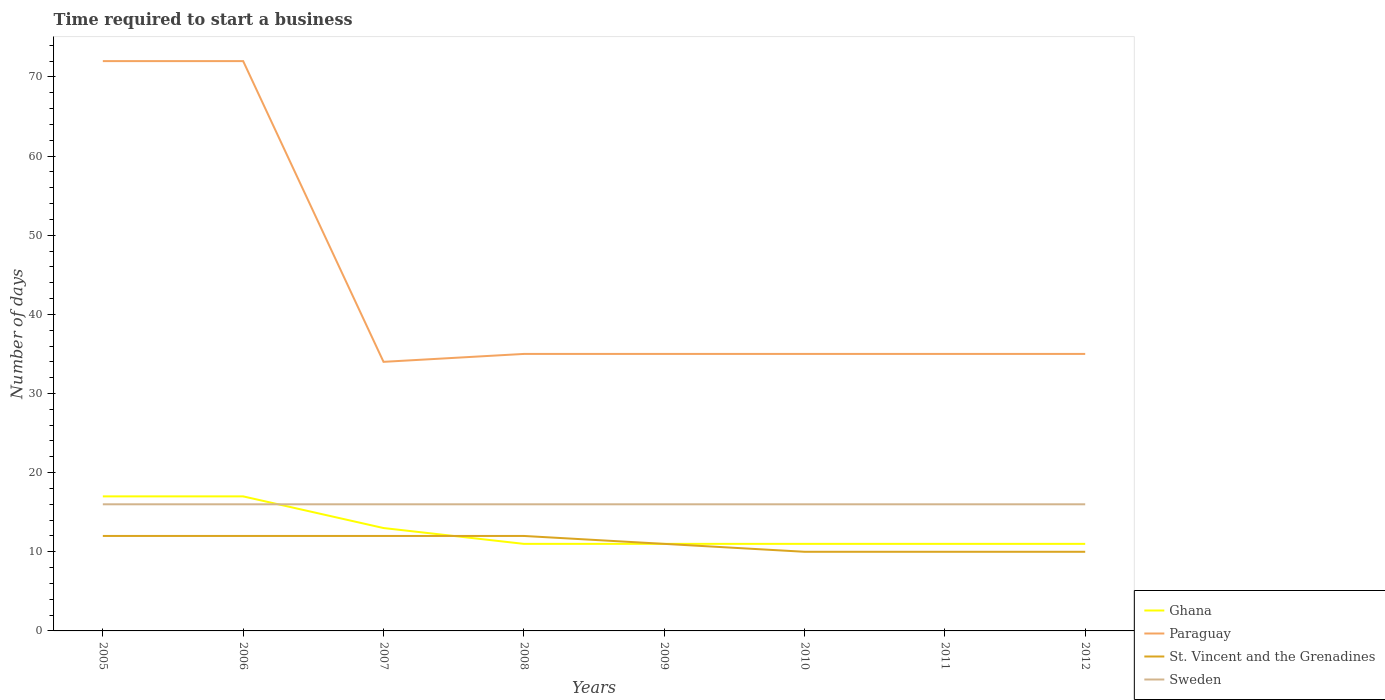How many different coloured lines are there?
Provide a short and direct response. 4. Across all years, what is the maximum number of days required to start a business in Paraguay?
Make the answer very short. 34. In which year was the number of days required to start a business in Sweden maximum?
Ensure brevity in your answer.  2005. What is the difference between the highest and the second highest number of days required to start a business in Sweden?
Your response must be concise. 0. What is the difference between the highest and the lowest number of days required to start a business in Sweden?
Your answer should be compact. 0. How many lines are there?
Provide a succinct answer. 4. Does the graph contain any zero values?
Offer a terse response. No. Does the graph contain grids?
Offer a very short reply. No. Where does the legend appear in the graph?
Offer a terse response. Bottom right. What is the title of the graph?
Give a very brief answer. Time required to start a business. Does "France" appear as one of the legend labels in the graph?
Provide a succinct answer. No. What is the label or title of the Y-axis?
Your answer should be very brief. Number of days. What is the Number of days of St. Vincent and the Grenadines in 2005?
Your answer should be compact. 12. What is the Number of days of Sweden in 2005?
Give a very brief answer. 16. What is the Number of days of Ghana in 2008?
Keep it short and to the point. 11. What is the Number of days in Sweden in 2008?
Give a very brief answer. 16. What is the Number of days of Ghana in 2009?
Offer a terse response. 11. What is the Number of days of St. Vincent and the Grenadines in 2009?
Your answer should be very brief. 11. What is the Number of days in Sweden in 2009?
Keep it short and to the point. 16. What is the Number of days in Paraguay in 2010?
Your answer should be compact. 35. What is the Number of days of Sweden in 2010?
Offer a terse response. 16. What is the Number of days of Ghana in 2011?
Provide a short and direct response. 11. What is the Number of days in St. Vincent and the Grenadines in 2011?
Offer a terse response. 10. What is the Number of days in Sweden in 2011?
Offer a very short reply. 16. What is the Number of days of Ghana in 2012?
Offer a very short reply. 11. Across all years, what is the maximum Number of days of Ghana?
Keep it short and to the point. 17. Across all years, what is the maximum Number of days of St. Vincent and the Grenadines?
Give a very brief answer. 12. Across all years, what is the minimum Number of days of Ghana?
Your answer should be compact. 11. What is the total Number of days of Ghana in the graph?
Your response must be concise. 102. What is the total Number of days of Paraguay in the graph?
Your response must be concise. 353. What is the total Number of days of St. Vincent and the Grenadines in the graph?
Ensure brevity in your answer.  89. What is the total Number of days in Sweden in the graph?
Offer a terse response. 128. What is the difference between the Number of days of Paraguay in 2005 and that in 2006?
Offer a very short reply. 0. What is the difference between the Number of days of St. Vincent and the Grenadines in 2005 and that in 2006?
Provide a succinct answer. 0. What is the difference between the Number of days of Sweden in 2005 and that in 2006?
Provide a succinct answer. 0. What is the difference between the Number of days in St. Vincent and the Grenadines in 2005 and that in 2007?
Provide a succinct answer. 0. What is the difference between the Number of days of Sweden in 2005 and that in 2007?
Provide a short and direct response. 0. What is the difference between the Number of days of St. Vincent and the Grenadines in 2005 and that in 2008?
Your answer should be very brief. 0. What is the difference between the Number of days in Ghana in 2005 and that in 2009?
Your answer should be compact. 6. What is the difference between the Number of days of St. Vincent and the Grenadines in 2005 and that in 2009?
Your answer should be compact. 1. What is the difference between the Number of days in Ghana in 2005 and that in 2011?
Provide a succinct answer. 6. What is the difference between the Number of days in Paraguay in 2005 and that in 2011?
Offer a very short reply. 37. What is the difference between the Number of days of Sweden in 2005 and that in 2011?
Offer a terse response. 0. What is the difference between the Number of days of Ghana in 2005 and that in 2012?
Make the answer very short. 6. What is the difference between the Number of days in Paraguay in 2005 and that in 2012?
Offer a very short reply. 37. What is the difference between the Number of days of St. Vincent and the Grenadines in 2005 and that in 2012?
Your answer should be very brief. 2. What is the difference between the Number of days in St. Vincent and the Grenadines in 2006 and that in 2007?
Make the answer very short. 0. What is the difference between the Number of days in Sweden in 2006 and that in 2007?
Ensure brevity in your answer.  0. What is the difference between the Number of days of Paraguay in 2006 and that in 2008?
Make the answer very short. 37. What is the difference between the Number of days of Sweden in 2006 and that in 2008?
Offer a terse response. 0. What is the difference between the Number of days in St. Vincent and the Grenadines in 2006 and that in 2009?
Make the answer very short. 1. What is the difference between the Number of days in Sweden in 2006 and that in 2009?
Provide a succinct answer. 0. What is the difference between the Number of days of Paraguay in 2006 and that in 2010?
Offer a very short reply. 37. What is the difference between the Number of days in Ghana in 2006 and that in 2011?
Make the answer very short. 6. What is the difference between the Number of days of Paraguay in 2006 and that in 2011?
Keep it short and to the point. 37. What is the difference between the Number of days in St. Vincent and the Grenadines in 2006 and that in 2011?
Your answer should be compact. 2. What is the difference between the Number of days of Ghana in 2006 and that in 2012?
Keep it short and to the point. 6. What is the difference between the Number of days of Sweden in 2006 and that in 2012?
Provide a short and direct response. 0. What is the difference between the Number of days in Ghana in 2007 and that in 2008?
Make the answer very short. 2. What is the difference between the Number of days in Paraguay in 2007 and that in 2008?
Provide a short and direct response. -1. What is the difference between the Number of days in St. Vincent and the Grenadines in 2007 and that in 2008?
Provide a succinct answer. 0. What is the difference between the Number of days in Paraguay in 2007 and that in 2009?
Offer a very short reply. -1. What is the difference between the Number of days of St. Vincent and the Grenadines in 2007 and that in 2009?
Your answer should be compact. 1. What is the difference between the Number of days in St. Vincent and the Grenadines in 2007 and that in 2010?
Provide a succinct answer. 2. What is the difference between the Number of days of Ghana in 2007 and that in 2011?
Your answer should be compact. 2. What is the difference between the Number of days of Ghana in 2007 and that in 2012?
Your answer should be compact. 2. What is the difference between the Number of days of Paraguay in 2007 and that in 2012?
Make the answer very short. -1. What is the difference between the Number of days in St. Vincent and the Grenadines in 2007 and that in 2012?
Your answer should be very brief. 2. What is the difference between the Number of days in Ghana in 2008 and that in 2009?
Ensure brevity in your answer.  0. What is the difference between the Number of days of Paraguay in 2008 and that in 2009?
Your answer should be very brief. 0. What is the difference between the Number of days in Ghana in 2008 and that in 2010?
Offer a terse response. 0. What is the difference between the Number of days of St. Vincent and the Grenadines in 2008 and that in 2010?
Offer a terse response. 2. What is the difference between the Number of days of St. Vincent and the Grenadines in 2008 and that in 2011?
Ensure brevity in your answer.  2. What is the difference between the Number of days of Ghana in 2008 and that in 2012?
Your answer should be very brief. 0. What is the difference between the Number of days of Paraguay in 2008 and that in 2012?
Your response must be concise. 0. What is the difference between the Number of days in St. Vincent and the Grenadines in 2008 and that in 2012?
Make the answer very short. 2. What is the difference between the Number of days in Sweden in 2008 and that in 2012?
Offer a terse response. 0. What is the difference between the Number of days in Paraguay in 2009 and that in 2010?
Provide a succinct answer. 0. What is the difference between the Number of days of St. Vincent and the Grenadines in 2009 and that in 2010?
Offer a terse response. 1. What is the difference between the Number of days in Sweden in 2009 and that in 2010?
Your response must be concise. 0. What is the difference between the Number of days of Paraguay in 2009 and that in 2011?
Offer a terse response. 0. What is the difference between the Number of days in St. Vincent and the Grenadines in 2009 and that in 2011?
Provide a succinct answer. 1. What is the difference between the Number of days of Paraguay in 2009 and that in 2012?
Keep it short and to the point. 0. What is the difference between the Number of days of Sweden in 2010 and that in 2012?
Offer a very short reply. 0. What is the difference between the Number of days of Ghana in 2011 and that in 2012?
Provide a short and direct response. 0. What is the difference between the Number of days in Paraguay in 2011 and that in 2012?
Keep it short and to the point. 0. What is the difference between the Number of days of Sweden in 2011 and that in 2012?
Give a very brief answer. 0. What is the difference between the Number of days in Ghana in 2005 and the Number of days in Paraguay in 2006?
Give a very brief answer. -55. What is the difference between the Number of days of Paraguay in 2005 and the Number of days of St. Vincent and the Grenadines in 2006?
Make the answer very short. 60. What is the difference between the Number of days in Paraguay in 2005 and the Number of days in Sweden in 2006?
Offer a very short reply. 56. What is the difference between the Number of days of St. Vincent and the Grenadines in 2005 and the Number of days of Sweden in 2006?
Give a very brief answer. -4. What is the difference between the Number of days of Ghana in 2005 and the Number of days of Paraguay in 2007?
Provide a succinct answer. -17. What is the difference between the Number of days in Ghana in 2005 and the Number of days in Sweden in 2007?
Ensure brevity in your answer.  1. What is the difference between the Number of days in St. Vincent and the Grenadines in 2005 and the Number of days in Sweden in 2007?
Give a very brief answer. -4. What is the difference between the Number of days in Ghana in 2005 and the Number of days in St. Vincent and the Grenadines in 2008?
Give a very brief answer. 5. What is the difference between the Number of days in Ghana in 2005 and the Number of days in Sweden in 2008?
Ensure brevity in your answer.  1. What is the difference between the Number of days in Paraguay in 2005 and the Number of days in St. Vincent and the Grenadines in 2008?
Your answer should be very brief. 60. What is the difference between the Number of days in Paraguay in 2005 and the Number of days in Sweden in 2008?
Give a very brief answer. 56. What is the difference between the Number of days in St. Vincent and the Grenadines in 2005 and the Number of days in Sweden in 2009?
Keep it short and to the point. -4. What is the difference between the Number of days in Ghana in 2005 and the Number of days in St. Vincent and the Grenadines in 2010?
Make the answer very short. 7. What is the difference between the Number of days in Ghana in 2005 and the Number of days in Sweden in 2010?
Provide a short and direct response. 1. What is the difference between the Number of days in St. Vincent and the Grenadines in 2005 and the Number of days in Sweden in 2010?
Make the answer very short. -4. What is the difference between the Number of days in Ghana in 2005 and the Number of days in St. Vincent and the Grenadines in 2011?
Your answer should be compact. 7. What is the difference between the Number of days in Paraguay in 2005 and the Number of days in Sweden in 2011?
Provide a succinct answer. 56. What is the difference between the Number of days of St. Vincent and the Grenadines in 2005 and the Number of days of Sweden in 2011?
Provide a short and direct response. -4. What is the difference between the Number of days in Paraguay in 2005 and the Number of days in Sweden in 2012?
Ensure brevity in your answer.  56. What is the difference between the Number of days of St. Vincent and the Grenadines in 2005 and the Number of days of Sweden in 2012?
Your answer should be very brief. -4. What is the difference between the Number of days of Ghana in 2006 and the Number of days of Sweden in 2007?
Offer a terse response. 1. What is the difference between the Number of days of Paraguay in 2006 and the Number of days of St. Vincent and the Grenadines in 2007?
Keep it short and to the point. 60. What is the difference between the Number of days of Paraguay in 2006 and the Number of days of Sweden in 2007?
Your answer should be compact. 56. What is the difference between the Number of days of Ghana in 2006 and the Number of days of Paraguay in 2008?
Give a very brief answer. -18. What is the difference between the Number of days of Ghana in 2006 and the Number of days of St. Vincent and the Grenadines in 2008?
Make the answer very short. 5. What is the difference between the Number of days in Ghana in 2006 and the Number of days in Sweden in 2008?
Make the answer very short. 1. What is the difference between the Number of days in Paraguay in 2006 and the Number of days in Sweden in 2008?
Make the answer very short. 56. What is the difference between the Number of days in St. Vincent and the Grenadines in 2006 and the Number of days in Sweden in 2008?
Your answer should be very brief. -4. What is the difference between the Number of days in Ghana in 2006 and the Number of days in Paraguay in 2009?
Keep it short and to the point. -18. What is the difference between the Number of days of Paraguay in 2006 and the Number of days of St. Vincent and the Grenadines in 2009?
Provide a short and direct response. 61. What is the difference between the Number of days of Paraguay in 2006 and the Number of days of Sweden in 2009?
Ensure brevity in your answer.  56. What is the difference between the Number of days in Ghana in 2006 and the Number of days in Paraguay in 2010?
Provide a short and direct response. -18. What is the difference between the Number of days in Ghana in 2006 and the Number of days in St. Vincent and the Grenadines in 2010?
Give a very brief answer. 7. What is the difference between the Number of days in Ghana in 2006 and the Number of days in Sweden in 2010?
Your answer should be compact. 1. What is the difference between the Number of days in Paraguay in 2006 and the Number of days in St. Vincent and the Grenadines in 2010?
Provide a short and direct response. 62. What is the difference between the Number of days of Paraguay in 2006 and the Number of days of Sweden in 2010?
Provide a succinct answer. 56. What is the difference between the Number of days in Paraguay in 2006 and the Number of days in Sweden in 2011?
Offer a terse response. 56. What is the difference between the Number of days of St. Vincent and the Grenadines in 2006 and the Number of days of Sweden in 2011?
Provide a succinct answer. -4. What is the difference between the Number of days in Ghana in 2006 and the Number of days in St. Vincent and the Grenadines in 2012?
Your response must be concise. 7. What is the difference between the Number of days of Ghana in 2006 and the Number of days of Sweden in 2012?
Ensure brevity in your answer.  1. What is the difference between the Number of days in St. Vincent and the Grenadines in 2006 and the Number of days in Sweden in 2012?
Offer a terse response. -4. What is the difference between the Number of days of Ghana in 2007 and the Number of days of Paraguay in 2008?
Offer a very short reply. -22. What is the difference between the Number of days of Paraguay in 2007 and the Number of days of Sweden in 2008?
Your answer should be very brief. 18. What is the difference between the Number of days of St. Vincent and the Grenadines in 2007 and the Number of days of Sweden in 2008?
Your answer should be very brief. -4. What is the difference between the Number of days of Ghana in 2007 and the Number of days of Paraguay in 2009?
Make the answer very short. -22. What is the difference between the Number of days of Ghana in 2007 and the Number of days of St. Vincent and the Grenadines in 2009?
Your answer should be very brief. 2. What is the difference between the Number of days of Paraguay in 2007 and the Number of days of St. Vincent and the Grenadines in 2009?
Offer a very short reply. 23. What is the difference between the Number of days of Ghana in 2007 and the Number of days of Paraguay in 2010?
Your answer should be very brief. -22. What is the difference between the Number of days in Ghana in 2007 and the Number of days in Sweden in 2010?
Your response must be concise. -3. What is the difference between the Number of days in Paraguay in 2007 and the Number of days in St. Vincent and the Grenadines in 2010?
Offer a very short reply. 24. What is the difference between the Number of days in Paraguay in 2007 and the Number of days in Sweden in 2010?
Offer a terse response. 18. What is the difference between the Number of days in Ghana in 2007 and the Number of days in Paraguay in 2011?
Offer a terse response. -22. What is the difference between the Number of days in Paraguay in 2007 and the Number of days in St. Vincent and the Grenadines in 2011?
Provide a short and direct response. 24. What is the difference between the Number of days of Ghana in 2007 and the Number of days of St. Vincent and the Grenadines in 2012?
Provide a succinct answer. 3. What is the difference between the Number of days in Ghana in 2007 and the Number of days in Sweden in 2012?
Offer a very short reply. -3. What is the difference between the Number of days in Paraguay in 2007 and the Number of days in St. Vincent and the Grenadines in 2012?
Make the answer very short. 24. What is the difference between the Number of days in St. Vincent and the Grenadines in 2007 and the Number of days in Sweden in 2012?
Offer a very short reply. -4. What is the difference between the Number of days in Ghana in 2008 and the Number of days in Paraguay in 2009?
Your answer should be very brief. -24. What is the difference between the Number of days of Ghana in 2008 and the Number of days of Sweden in 2009?
Keep it short and to the point. -5. What is the difference between the Number of days of Ghana in 2008 and the Number of days of Sweden in 2010?
Give a very brief answer. -5. What is the difference between the Number of days of Paraguay in 2008 and the Number of days of Sweden in 2010?
Make the answer very short. 19. What is the difference between the Number of days in St. Vincent and the Grenadines in 2008 and the Number of days in Sweden in 2010?
Provide a short and direct response. -4. What is the difference between the Number of days of Ghana in 2008 and the Number of days of Paraguay in 2011?
Offer a very short reply. -24. What is the difference between the Number of days of Ghana in 2008 and the Number of days of Sweden in 2011?
Your answer should be compact. -5. What is the difference between the Number of days of Paraguay in 2008 and the Number of days of Sweden in 2011?
Offer a very short reply. 19. What is the difference between the Number of days in St. Vincent and the Grenadines in 2008 and the Number of days in Sweden in 2011?
Make the answer very short. -4. What is the difference between the Number of days in Ghana in 2008 and the Number of days in Paraguay in 2012?
Your answer should be compact. -24. What is the difference between the Number of days in Ghana in 2008 and the Number of days in Sweden in 2012?
Your answer should be compact. -5. What is the difference between the Number of days of St. Vincent and the Grenadines in 2008 and the Number of days of Sweden in 2012?
Your answer should be very brief. -4. What is the difference between the Number of days in Ghana in 2009 and the Number of days in St. Vincent and the Grenadines in 2010?
Ensure brevity in your answer.  1. What is the difference between the Number of days of Paraguay in 2009 and the Number of days of St. Vincent and the Grenadines in 2010?
Offer a terse response. 25. What is the difference between the Number of days of Paraguay in 2009 and the Number of days of St. Vincent and the Grenadines in 2011?
Provide a short and direct response. 25. What is the difference between the Number of days of Ghana in 2009 and the Number of days of Paraguay in 2012?
Your answer should be very brief. -24. What is the difference between the Number of days in Ghana in 2009 and the Number of days in St. Vincent and the Grenadines in 2012?
Your answer should be very brief. 1. What is the difference between the Number of days of St. Vincent and the Grenadines in 2009 and the Number of days of Sweden in 2012?
Offer a terse response. -5. What is the difference between the Number of days in Ghana in 2010 and the Number of days in Paraguay in 2011?
Your answer should be compact. -24. What is the difference between the Number of days in Ghana in 2010 and the Number of days in St. Vincent and the Grenadines in 2011?
Keep it short and to the point. 1. What is the difference between the Number of days of Ghana in 2010 and the Number of days of Sweden in 2011?
Your response must be concise. -5. What is the difference between the Number of days of Paraguay in 2010 and the Number of days of Sweden in 2011?
Your response must be concise. 19. What is the difference between the Number of days in St. Vincent and the Grenadines in 2010 and the Number of days in Sweden in 2011?
Ensure brevity in your answer.  -6. What is the difference between the Number of days of Paraguay in 2010 and the Number of days of St. Vincent and the Grenadines in 2012?
Your answer should be compact. 25. What is the difference between the Number of days in Ghana in 2011 and the Number of days in St. Vincent and the Grenadines in 2012?
Offer a very short reply. 1. What is the difference between the Number of days of Ghana in 2011 and the Number of days of Sweden in 2012?
Your response must be concise. -5. What is the difference between the Number of days in Paraguay in 2011 and the Number of days in Sweden in 2012?
Your answer should be very brief. 19. What is the average Number of days of Ghana per year?
Give a very brief answer. 12.75. What is the average Number of days of Paraguay per year?
Ensure brevity in your answer.  44.12. What is the average Number of days in St. Vincent and the Grenadines per year?
Your answer should be compact. 11.12. What is the average Number of days in Sweden per year?
Provide a succinct answer. 16. In the year 2005, what is the difference between the Number of days of Ghana and Number of days of Paraguay?
Provide a succinct answer. -55. In the year 2005, what is the difference between the Number of days of Ghana and Number of days of Sweden?
Keep it short and to the point. 1. In the year 2006, what is the difference between the Number of days of Ghana and Number of days of Paraguay?
Provide a short and direct response. -55. In the year 2006, what is the difference between the Number of days of Paraguay and Number of days of St. Vincent and the Grenadines?
Offer a very short reply. 60. In the year 2007, what is the difference between the Number of days in Ghana and Number of days in St. Vincent and the Grenadines?
Offer a very short reply. 1. In the year 2007, what is the difference between the Number of days in Paraguay and Number of days in Sweden?
Provide a succinct answer. 18. In the year 2008, what is the difference between the Number of days in Ghana and Number of days in St. Vincent and the Grenadines?
Give a very brief answer. -1. In the year 2008, what is the difference between the Number of days of Paraguay and Number of days of St. Vincent and the Grenadines?
Provide a succinct answer. 23. In the year 2009, what is the difference between the Number of days in Ghana and Number of days in Paraguay?
Ensure brevity in your answer.  -24. In the year 2009, what is the difference between the Number of days in Ghana and Number of days in St. Vincent and the Grenadines?
Make the answer very short. 0. In the year 2009, what is the difference between the Number of days in Paraguay and Number of days in Sweden?
Give a very brief answer. 19. In the year 2010, what is the difference between the Number of days of Ghana and Number of days of Sweden?
Give a very brief answer. -5. In the year 2010, what is the difference between the Number of days in Paraguay and Number of days in Sweden?
Provide a short and direct response. 19. In the year 2010, what is the difference between the Number of days in St. Vincent and the Grenadines and Number of days in Sweden?
Offer a terse response. -6. In the year 2011, what is the difference between the Number of days in Ghana and Number of days in St. Vincent and the Grenadines?
Keep it short and to the point. 1. In the year 2011, what is the difference between the Number of days of St. Vincent and the Grenadines and Number of days of Sweden?
Provide a short and direct response. -6. In the year 2012, what is the difference between the Number of days of Ghana and Number of days of Sweden?
Give a very brief answer. -5. In the year 2012, what is the difference between the Number of days of Paraguay and Number of days of St. Vincent and the Grenadines?
Make the answer very short. 25. In the year 2012, what is the difference between the Number of days in Paraguay and Number of days in Sweden?
Offer a terse response. 19. In the year 2012, what is the difference between the Number of days in St. Vincent and the Grenadines and Number of days in Sweden?
Your response must be concise. -6. What is the ratio of the Number of days of Ghana in 2005 to that in 2006?
Give a very brief answer. 1. What is the ratio of the Number of days in Ghana in 2005 to that in 2007?
Provide a succinct answer. 1.31. What is the ratio of the Number of days of Paraguay in 2005 to that in 2007?
Your response must be concise. 2.12. What is the ratio of the Number of days in Ghana in 2005 to that in 2008?
Offer a terse response. 1.55. What is the ratio of the Number of days of Paraguay in 2005 to that in 2008?
Offer a terse response. 2.06. What is the ratio of the Number of days of St. Vincent and the Grenadines in 2005 to that in 2008?
Your answer should be compact. 1. What is the ratio of the Number of days of Sweden in 2005 to that in 2008?
Make the answer very short. 1. What is the ratio of the Number of days of Ghana in 2005 to that in 2009?
Your answer should be very brief. 1.55. What is the ratio of the Number of days of Paraguay in 2005 to that in 2009?
Ensure brevity in your answer.  2.06. What is the ratio of the Number of days of St. Vincent and the Grenadines in 2005 to that in 2009?
Provide a short and direct response. 1.09. What is the ratio of the Number of days of Ghana in 2005 to that in 2010?
Ensure brevity in your answer.  1.55. What is the ratio of the Number of days in Paraguay in 2005 to that in 2010?
Make the answer very short. 2.06. What is the ratio of the Number of days of St. Vincent and the Grenadines in 2005 to that in 2010?
Your answer should be compact. 1.2. What is the ratio of the Number of days in Ghana in 2005 to that in 2011?
Make the answer very short. 1.55. What is the ratio of the Number of days of Paraguay in 2005 to that in 2011?
Ensure brevity in your answer.  2.06. What is the ratio of the Number of days of St. Vincent and the Grenadines in 2005 to that in 2011?
Provide a short and direct response. 1.2. What is the ratio of the Number of days of Ghana in 2005 to that in 2012?
Your answer should be compact. 1.55. What is the ratio of the Number of days of Paraguay in 2005 to that in 2012?
Give a very brief answer. 2.06. What is the ratio of the Number of days of St. Vincent and the Grenadines in 2005 to that in 2012?
Your response must be concise. 1.2. What is the ratio of the Number of days of Sweden in 2005 to that in 2012?
Provide a short and direct response. 1. What is the ratio of the Number of days in Ghana in 2006 to that in 2007?
Provide a short and direct response. 1.31. What is the ratio of the Number of days of Paraguay in 2006 to that in 2007?
Ensure brevity in your answer.  2.12. What is the ratio of the Number of days of Sweden in 2006 to that in 2007?
Make the answer very short. 1. What is the ratio of the Number of days in Ghana in 2006 to that in 2008?
Your answer should be very brief. 1.55. What is the ratio of the Number of days in Paraguay in 2006 to that in 2008?
Give a very brief answer. 2.06. What is the ratio of the Number of days in St. Vincent and the Grenadines in 2006 to that in 2008?
Offer a terse response. 1. What is the ratio of the Number of days in Ghana in 2006 to that in 2009?
Make the answer very short. 1.55. What is the ratio of the Number of days of Paraguay in 2006 to that in 2009?
Provide a short and direct response. 2.06. What is the ratio of the Number of days in Sweden in 2006 to that in 2009?
Keep it short and to the point. 1. What is the ratio of the Number of days in Ghana in 2006 to that in 2010?
Make the answer very short. 1.55. What is the ratio of the Number of days of Paraguay in 2006 to that in 2010?
Your answer should be very brief. 2.06. What is the ratio of the Number of days in Sweden in 2006 to that in 2010?
Your answer should be very brief. 1. What is the ratio of the Number of days in Ghana in 2006 to that in 2011?
Your answer should be compact. 1.55. What is the ratio of the Number of days in Paraguay in 2006 to that in 2011?
Your answer should be very brief. 2.06. What is the ratio of the Number of days of St. Vincent and the Grenadines in 2006 to that in 2011?
Keep it short and to the point. 1.2. What is the ratio of the Number of days of Ghana in 2006 to that in 2012?
Provide a succinct answer. 1.55. What is the ratio of the Number of days of Paraguay in 2006 to that in 2012?
Give a very brief answer. 2.06. What is the ratio of the Number of days of Ghana in 2007 to that in 2008?
Provide a succinct answer. 1.18. What is the ratio of the Number of days in Paraguay in 2007 to that in 2008?
Make the answer very short. 0.97. What is the ratio of the Number of days of St. Vincent and the Grenadines in 2007 to that in 2008?
Offer a terse response. 1. What is the ratio of the Number of days in Ghana in 2007 to that in 2009?
Keep it short and to the point. 1.18. What is the ratio of the Number of days in Paraguay in 2007 to that in 2009?
Ensure brevity in your answer.  0.97. What is the ratio of the Number of days of Sweden in 2007 to that in 2009?
Provide a short and direct response. 1. What is the ratio of the Number of days in Ghana in 2007 to that in 2010?
Ensure brevity in your answer.  1.18. What is the ratio of the Number of days in Paraguay in 2007 to that in 2010?
Make the answer very short. 0.97. What is the ratio of the Number of days of Ghana in 2007 to that in 2011?
Give a very brief answer. 1.18. What is the ratio of the Number of days of Paraguay in 2007 to that in 2011?
Your answer should be very brief. 0.97. What is the ratio of the Number of days in St. Vincent and the Grenadines in 2007 to that in 2011?
Provide a succinct answer. 1.2. What is the ratio of the Number of days of Ghana in 2007 to that in 2012?
Provide a succinct answer. 1.18. What is the ratio of the Number of days of Paraguay in 2007 to that in 2012?
Your response must be concise. 0.97. What is the ratio of the Number of days in Sweden in 2007 to that in 2012?
Your answer should be compact. 1. What is the ratio of the Number of days of Paraguay in 2008 to that in 2009?
Keep it short and to the point. 1. What is the ratio of the Number of days in Paraguay in 2008 to that in 2010?
Your answer should be compact. 1. What is the ratio of the Number of days of St. Vincent and the Grenadines in 2008 to that in 2010?
Ensure brevity in your answer.  1.2. What is the ratio of the Number of days of Sweden in 2008 to that in 2010?
Ensure brevity in your answer.  1. What is the ratio of the Number of days of St. Vincent and the Grenadines in 2008 to that in 2011?
Keep it short and to the point. 1.2. What is the ratio of the Number of days of Sweden in 2008 to that in 2011?
Make the answer very short. 1. What is the ratio of the Number of days in St. Vincent and the Grenadines in 2008 to that in 2012?
Ensure brevity in your answer.  1.2. What is the ratio of the Number of days of Sweden in 2009 to that in 2010?
Provide a short and direct response. 1. What is the ratio of the Number of days of Ghana in 2009 to that in 2011?
Give a very brief answer. 1. What is the ratio of the Number of days in Paraguay in 2009 to that in 2011?
Offer a very short reply. 1. What is the ratio of the Number of days of Sweden in 2009 to that in 2011?
Ensure brevity in your answer.  1. What is the ratio of the Number of days in Paraguay in 2009 to that in 2012?
Make the answer very short. 1. What is the ratio of the Number of days of Paraguay in 2010 to that in 2011?
Offer a terse response. 1. What is the ratio of the Number of days of Sweden in 2010 to that in 2011?
Your answer should be compact. 1. What is the ratio of the Number of days in St. Vincent and the Grenadines in 2010 to that in 2012?
Provide a short and direct response. 1. What is the ratio of the Number of days of Sweden in 2010 to that in 2012?
Your answer should be very brief. 1. What is the ratio of the Number of days of Ghana in 2011 to that in 2012?
Provide a short and direct response. 1. What is the ratio of the Number of days of Sweden in 2011 to that in 2012?
Keep it short and to the point. 1. What is the difference between the highest and the second highest Number of days of Ghana?
Your response must be concise. 0. What is the difference between the highest and the second highest Number of days of Paraguay?
Offer a terse response. 0. What is the difference between the highest and the second highest Number of days of St. Vincent and the Grenadines?
Make the answer very short. 0. What is the difference between the highest and the second highest Number of days in Sweden?
Provide a short and direct response. 0. What is the difference between the highest and the lowest Number of days of Ghana?
Provide a succinct answer. 6. What is the difference between the highest and the lowest Number of days in Paraguay?
Provide a succinct answer. 38. What is the difference between the highest and the lowest Number of days of Sweden?
Your answer should be very brief. 0. 